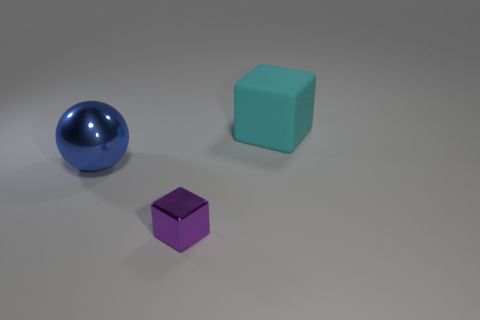Are there fewer tiny green metal cylinders than tiny purple metallic objects?
Keep it short and to the point. Yes. Are there any other things that have the same size as the blue metal sphere?
Your answer should be compact. Yes. There is another thing that is the same shape as the cyan rubber thing; what is it made of?
Your answer should be compact. Metal. Are there more tiny purple shiny things than small brown metallic things?
Provide a succinct answer. Yes. Is the cyan cube made of the same material as the big blue thing behind the tiny object?
Offer a terse response. No. What number of blue objects are in front of the big object that is behind the large object left of the big block?
Ensure brevity in your answer.  1. Are there fewer spheres in front of the tiny metal object than tiny cubes behind the big block?
Ensure brevity in your answer.  No. What number of other things are the same material as the tiny object?
Keep it short and to the point. 1. There is a blue thing that is the same size as the cyan cube; what is its material?
Offer a very short reply. Metal. What number of blue objects are either metallic objects or large rubber objects?
Your response must be concise. 1. 